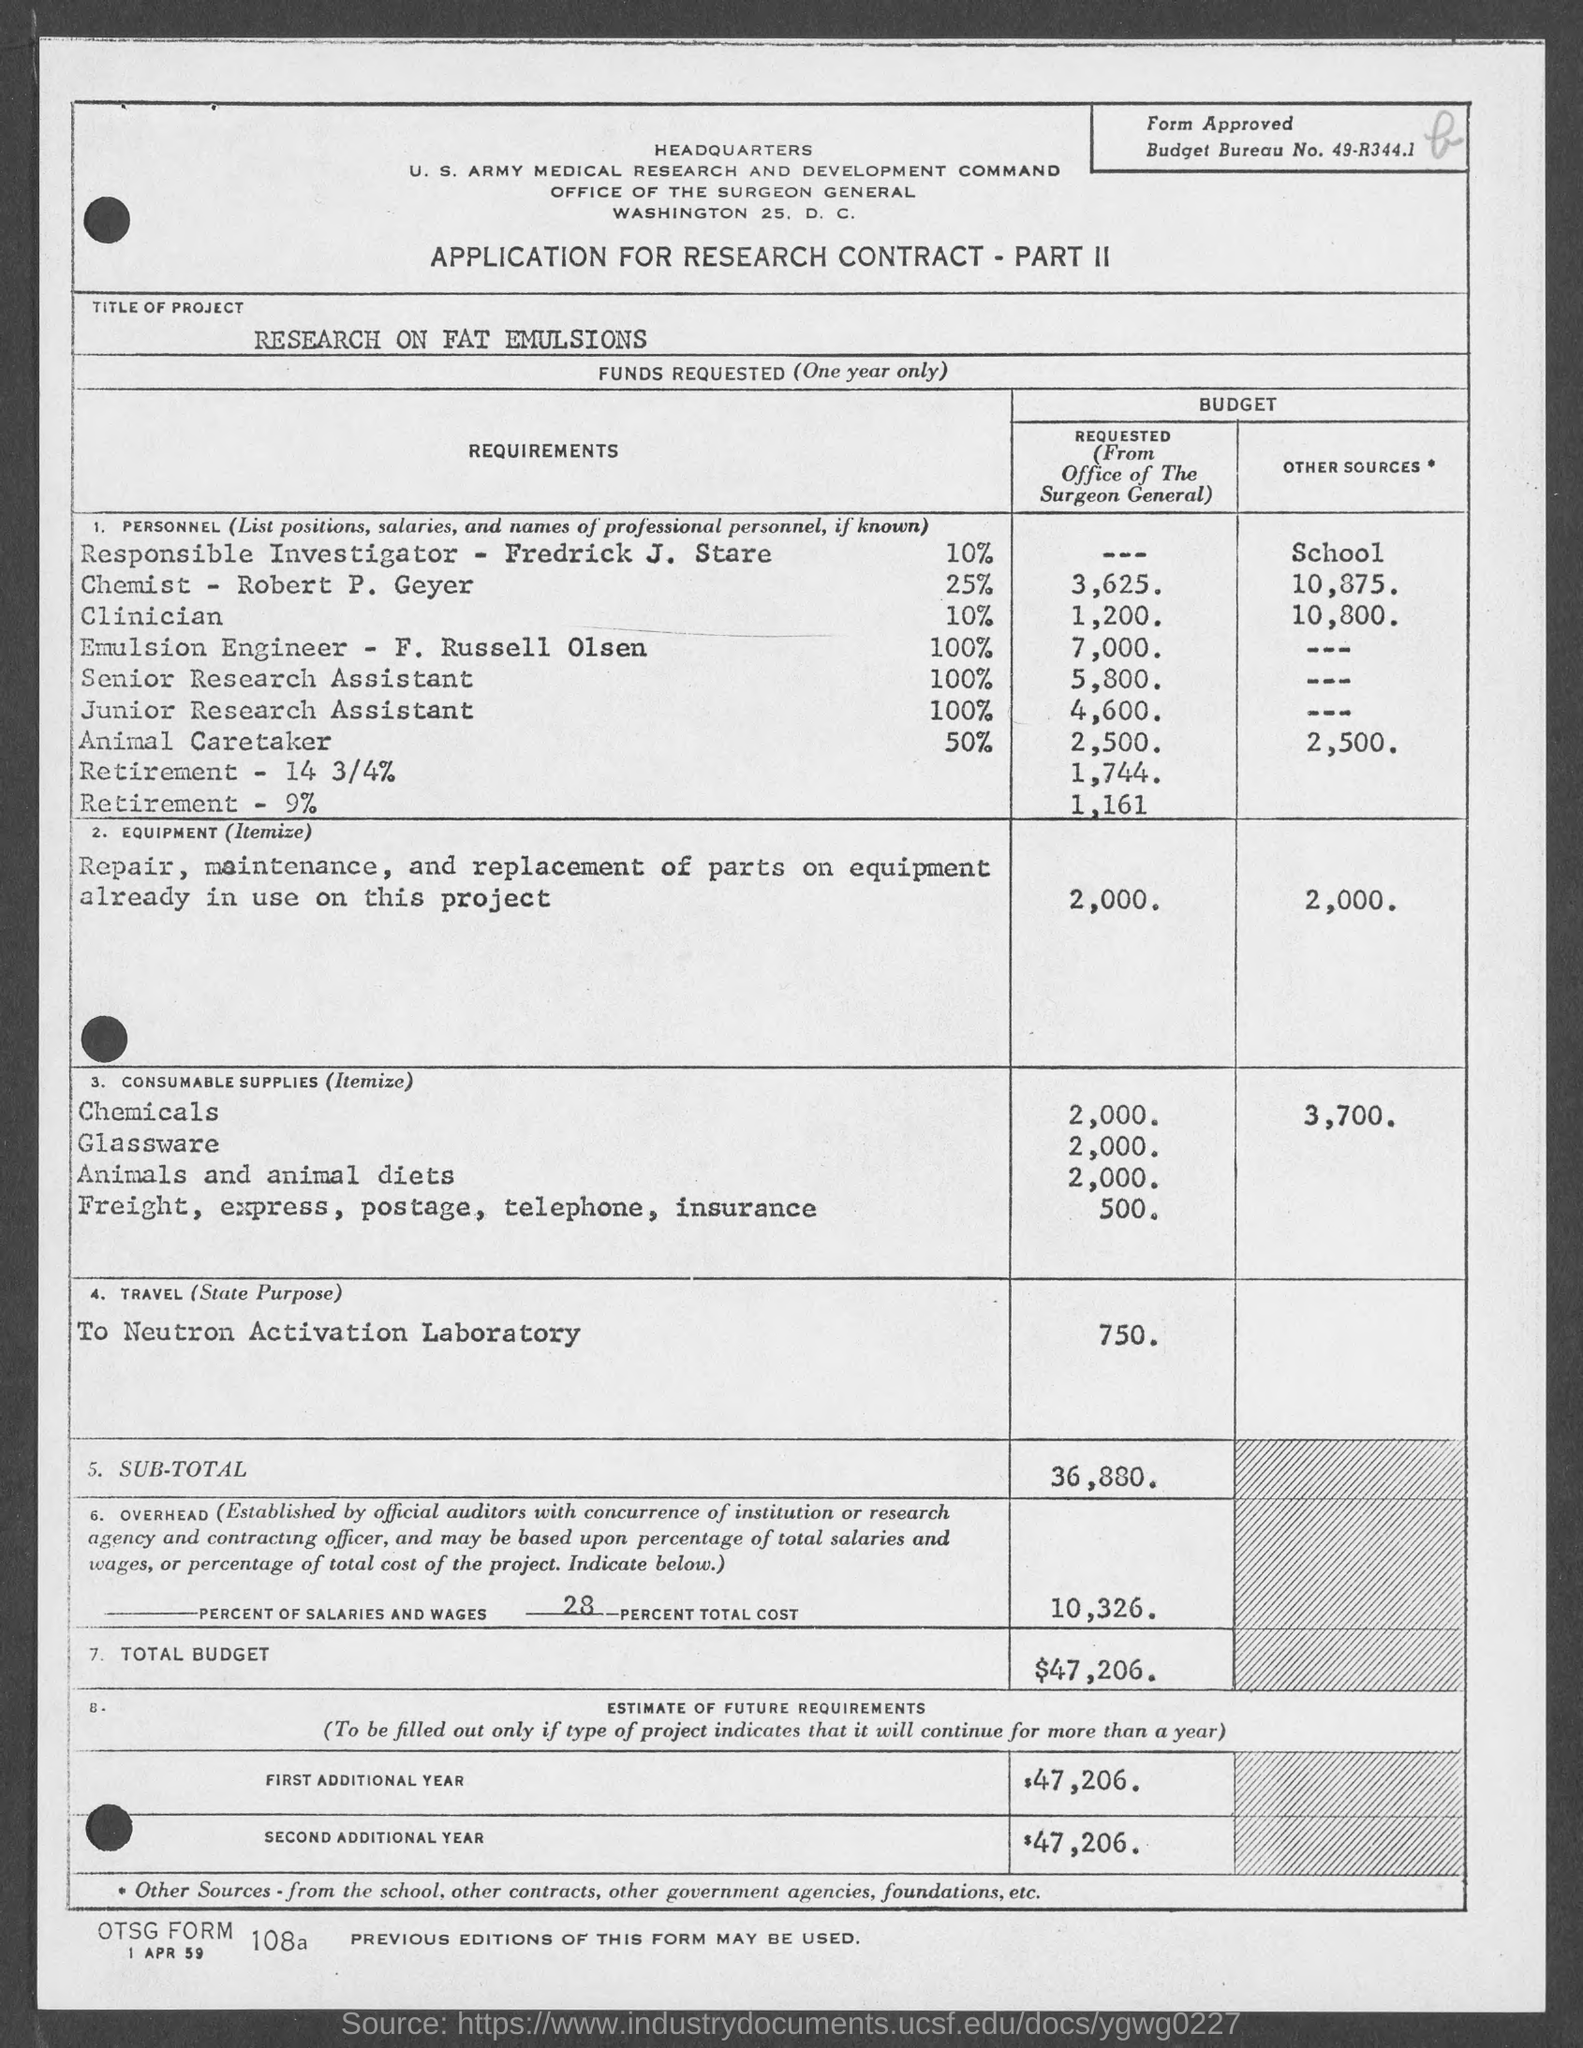Indicate a few pertinent items in this graphic. The application is intended for research purposes under the terms of a contract. The first additional year budget is estimated to be $47,206. What is OTSG form no. 108a?" is a question. The address of the Office of the Surgeon General is located in Washington, D.C., at 25. The total budget for the project is $47,206. 